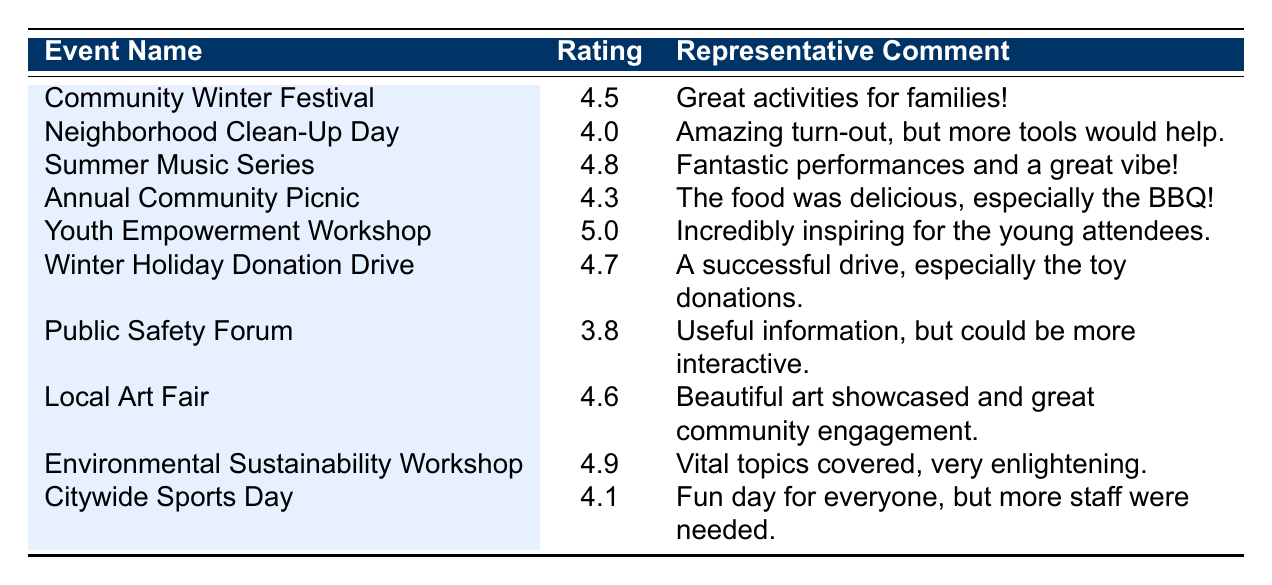What was the highest feedback rating for an event? The table shows the ratings for all events. The Youth Empowerment Workshop has the highest rating of 5.0.
Answer: 5.0 Which event received a rating lower than 4.0? By examining the ratings, the only event with a rating below 4.0 is the Public Safety Forum, which has a rating of 3.8.
Answer: Yes How many events had a rating of 4.5 or higher? Counting the events with ratings of 4.5 and above: Community Winter Festival (4.5), Summer Music Series (4.8), Youth Empowerment Workshop (5.0), Winter Holiday Donation Drive (4.7), Local Art Fair (4.6), Environmental Sustainability Workshop (4.9), and Citywide Sports Day (4.1) gives us a total of 7 events.
Answer: 7 What is the average rating of all the events listed in the table? The ratings are 4.5, 4.0, 4.8, 4.3, 5.0, 4.7, 3.8, 4.6, 4.9, and 4.1. Summing these gives 46.7. There are 10 events, so the average is 46.7 / 10 = 4.67.
Answer: 4.67 Did the Neighborhood Clean-Up Day receive a better rating than the Annual Community Picnic? Comparing the ratings, the Neighborhood Clean-Up Day has a rating of 4.0, while the Annual Community Picnic has a rating of 4.3. Since 4.3 is greater than 4.0, the Picnic did have a better rating.
Answer: Yes Which event had the most positive feedback based on comments? The Youth Empowerment Workshop received comments that described it as "Incredibly inspiring for the young attendees" and "Great facilitators who connected well with the youth," which are highly positive.
Answer: Youth Empowerment Workshop What was the average rating of the events related to community engagement and service? The relevant events are the Neighborhood Clean-Up Day (4.0), Winter Holiday Donation Drive (4.7), Public Safety Forum (3.8), and Citywide Sports Day (4.1). Adding these ratings gives 4.0 + 4.7 + 3.8 + 4.1 = 16.6. The average rating is 16.6 / 4 = 4.15.
Answer: 4.15 Which event received the lowest rating of the year, and what was the rating? The lowest rating is found by looking at the ratings, and the Public Safety Forum has the lowest score of 3.8.
Answer: Public Safety Forum, 3.8 Are there any events that had above 4.5 ratings and received a comment focused on improvement? Among events rated above 4.5, we check the comments. The Annual Community Picnic (4.3) suggests needing more seating, which is an improvement comment, though it has a rating just below 4.5. So, there are no events above 4.5 with an improvement comment.
Answer: No Which event was marked with the highest enthusiasm in the comments? The comments for the Summer Music Series, where feedback includes "Fantastic performances and a great vibe!" indicate a high level of enthusiasm.
Answer: Summer Music Series 